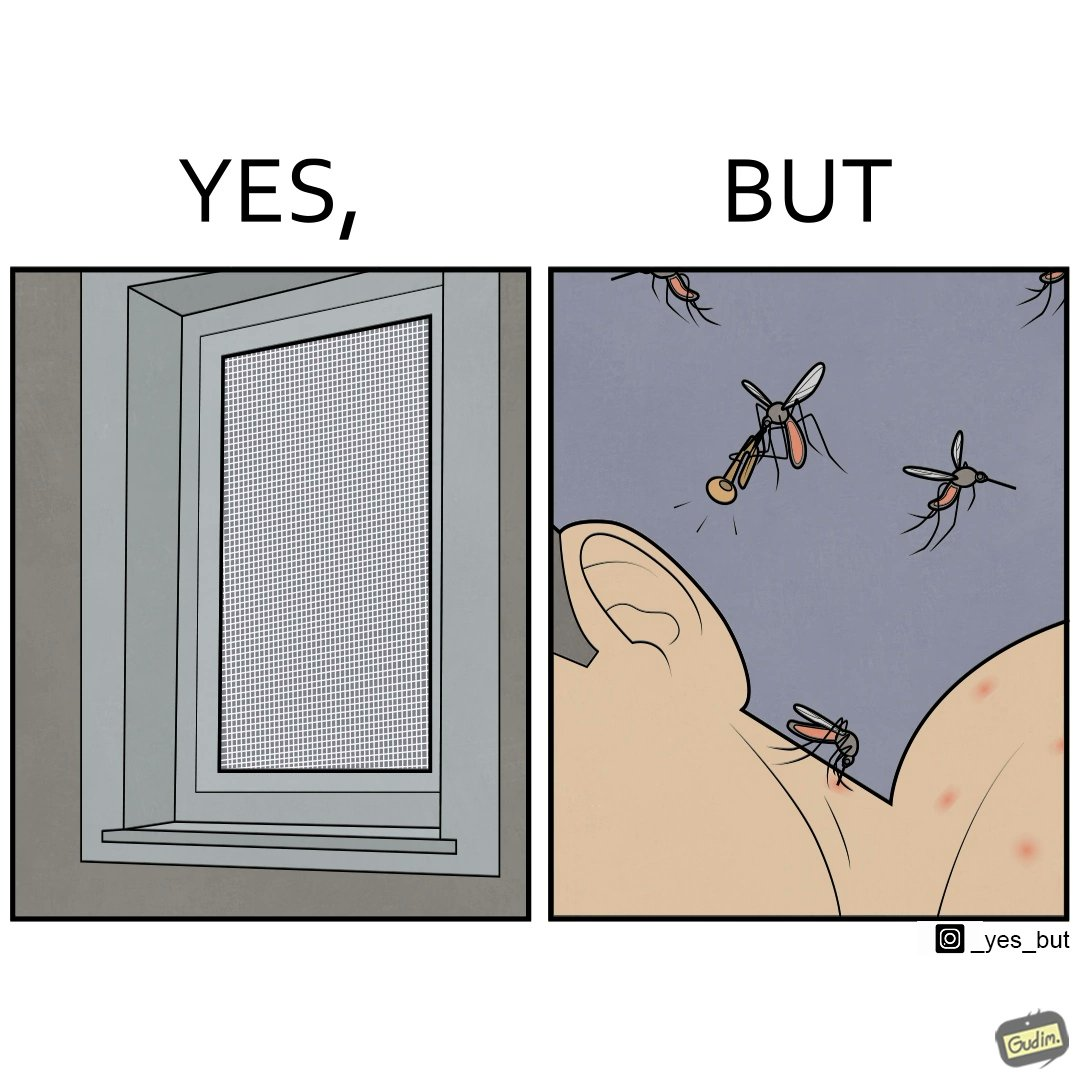What makes this image funny or satirical? The images are funny since it shows how even though we try to keep mosquitoes away from us using methods like mosquito nets, they still find a way to ruin our sleep by biting and making noise 